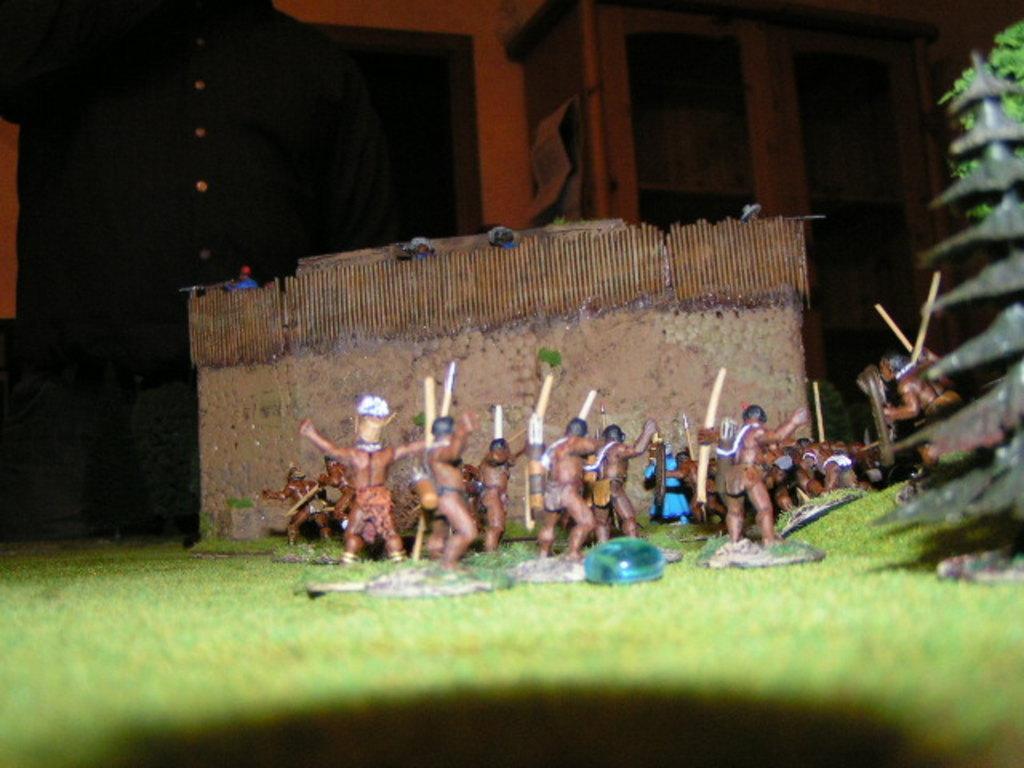How would you summarize this image in a sentence or two? In this image in the center there are toys and there is carpet grass. In the background there are persons and there is a cupboard. 